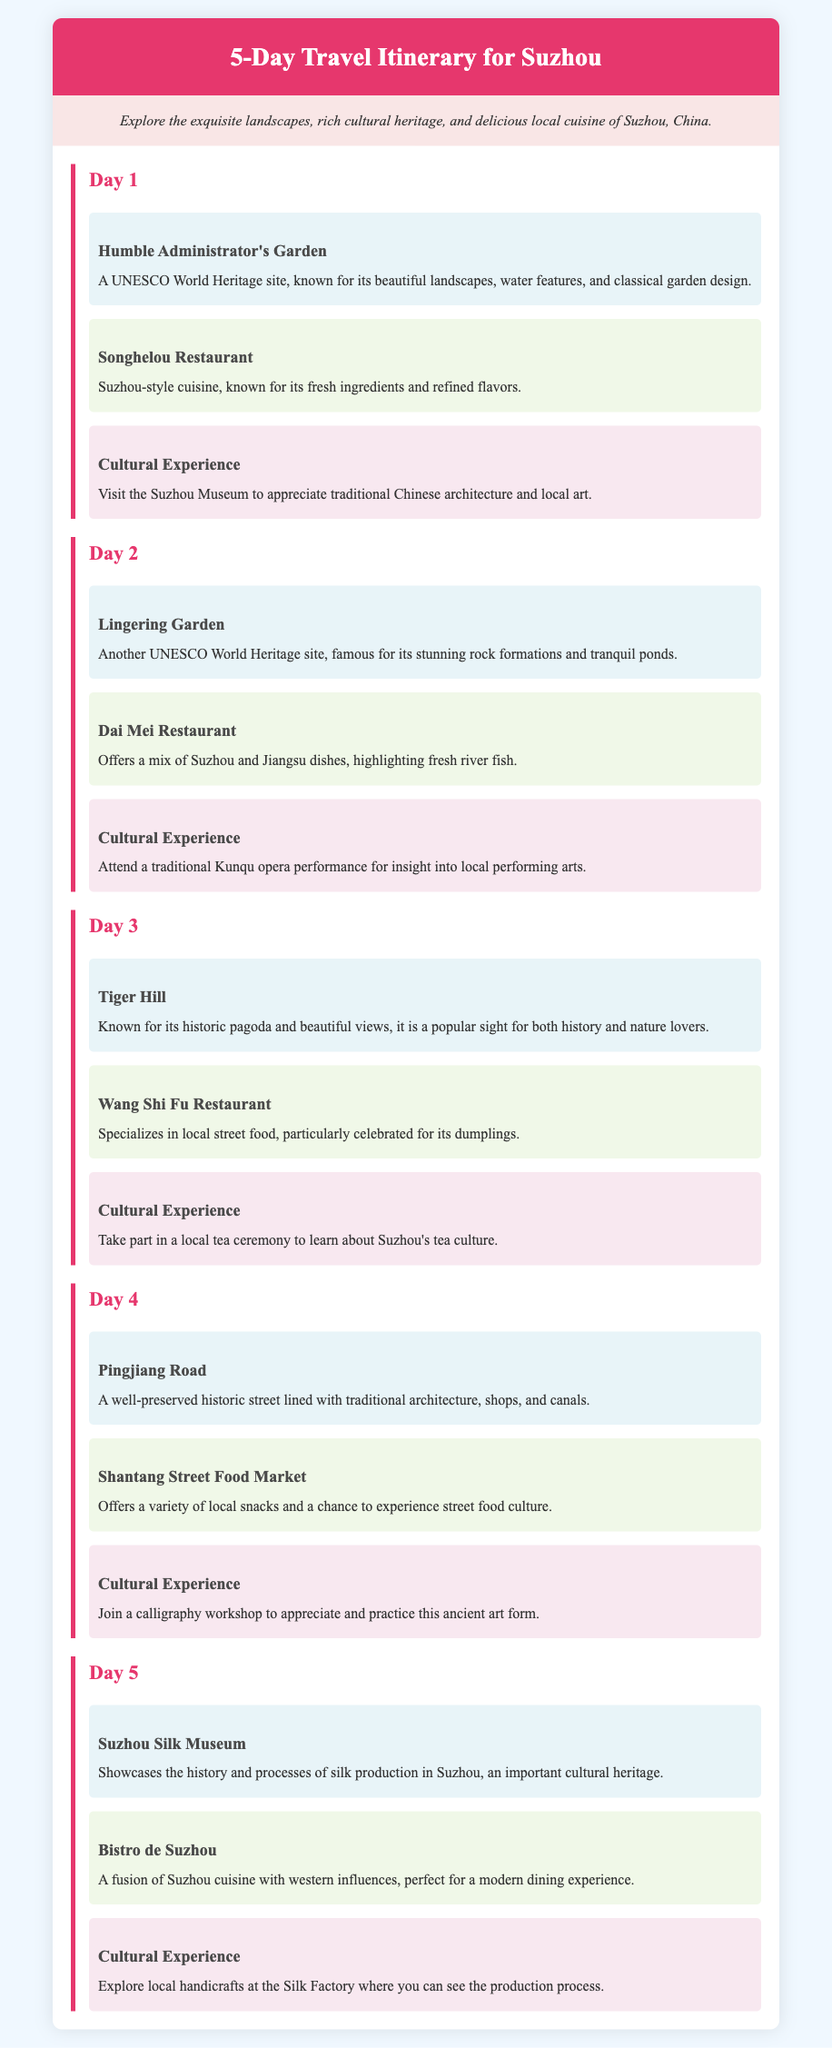What is the name of the first attraction? The first attraction listed in the itinerary is the Humble Administrator's Garden.
Answer: Humble Administrator's Garden How many days does the itinerary cover? The itinerary outlines activities for five distinct days of travel.
Answer: 5 Which restaurant specializes in local street food? The restaurant noted for specializing in local street food, particularly dumplings, is Wang Shi Fu Restaurant.
Answer: Wang Shi Fu Restaurant What cultural experience is offered on Day 2? On Day 2, visitors can attend a traditional Kunqu opera performance.
Answer: Kunqu opera performance What is the highlight of the Suzhou Silk Museum? The Suzhou Silk Museum showcases the history and processes of silk production in Suzhou.
Answer: Silk production Which attraction is associated with rock formations? The Lingering Garden is famous for its stunning rock formations.
Answer: Lingering Garden What type of culinary experience can tourists have on Day 4? Tourists can experience a variety of local snacks at the Shantang Street Food Market.
Answer: Street food market Which dining option offers a fusion with western influences? Bistro de Suzhou is the restaurant that blends Suzhou cuisine with western influences.
Answer: Bistro de Suzhou 